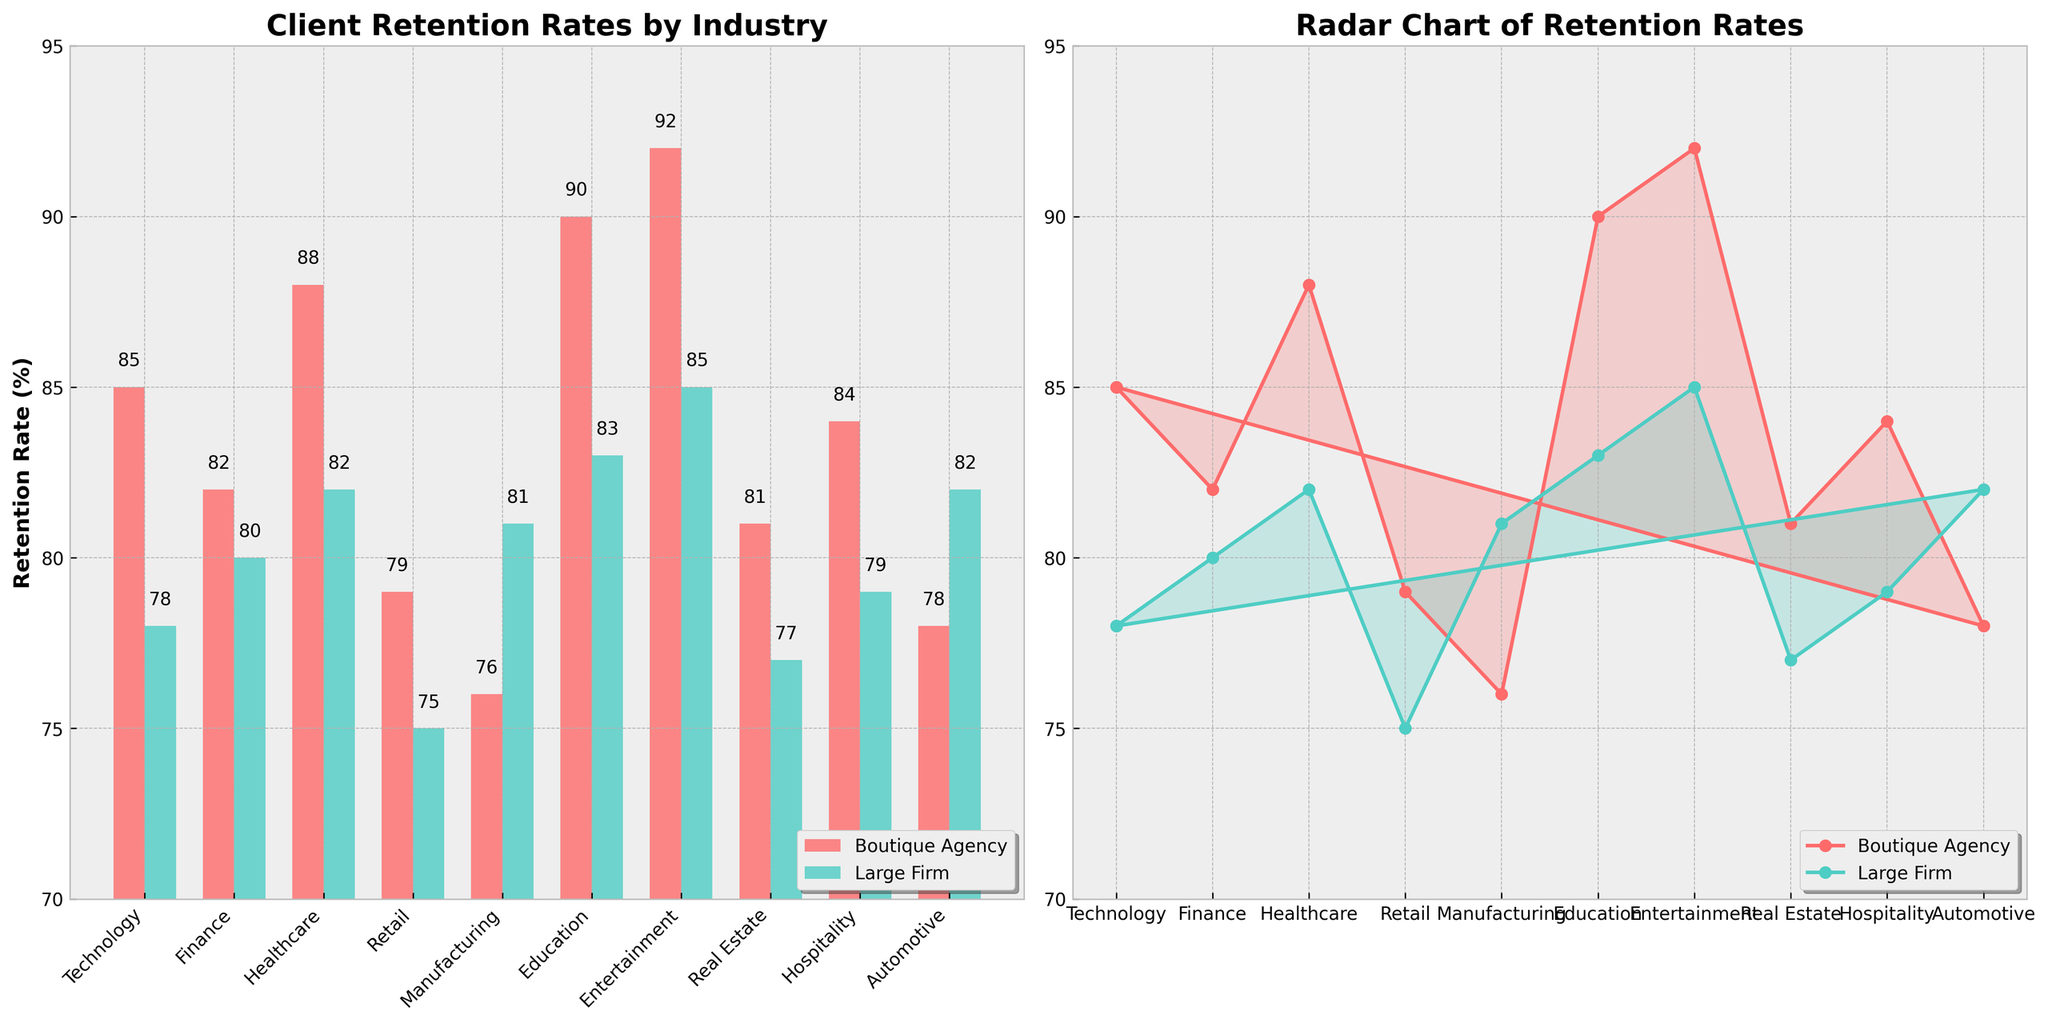what are the colors used for Boutique Agency and Large Firm in the bar chart? The bar chart uses distinct colors for the two types of agencies. Boutique Agency is represented by a red-like color, and Large Firm by a teal-like color. This color distinction helps in easily differentiating between the two in the chart.
Answer: red and teal which industry has the highest retention rate for Boutique Agencies? By looking at the bar heights in the bar chart, the Entertainment industry shows the tallest bar for Boutique Agencies, indicating the highest retention rate.
Answer: Entertainment which industry has the lowest retention rate in the radar chart, and for which type of agency? Comparing the plotted points on the radar chart, the Manufacturing industry has the lowest point for Boutique Agencies, indicating the lowest retention rate.
Answer: Manufacturing, Boutique Agency what is the difference in retention rates between Boutique Agencies and Large Firms in the Finance sector? In the bar chart, the Boutique Agency's retention rate for Finance is 82% and the Large Firm's is 80%. The difference is found by subtracting 80 from 82.
Answer: 2% what is the average retention rate for Large Firms across all industries? By adding all the retention rates for Large Firms and dividing by the number of industries, we get the average. The sum is (78+80+82+75+81+83+85+77+79+82) = 802. The average is 802 / 10 = 80.2%.
Answer: 80.2% which industry shows an equal retention rate between Boutique Agencies and Large Firms, if any? By examining both the bar and radar charts, no industry shows equal retention rates between Boutique Agencies and Large Firms; all industries have varying retention rates between the two types.
Answer: None in which industry is the retention rate for Large Firms greater than that for Boutique Agencies? In the bar chart, the retention rate for Large Firms is greater than Boutique Agencies in the Manufacturing industry, where Large Firms have 81% and Boutique Agencies have 76%.
Answer: Manufacturing what is the overall range of retention rates shown in the radar chart? The radar chart's retention rates for both Boutique Agencies and Large Firms range from the minimum of 75% to the maximum of 92%. This can be determined by visually identifying the lowest and highest points on the radar chart.
Answer: 75% to 92% which agency type has a higher retention rate in the Real Estate industry, and by how much? The bar chart shows Boutique Agencies with an 81% retention rate in Real Estate, and Large Firms with 77%. The difference is 81 - 77.
Answer: Boutique Agencies, 4% 